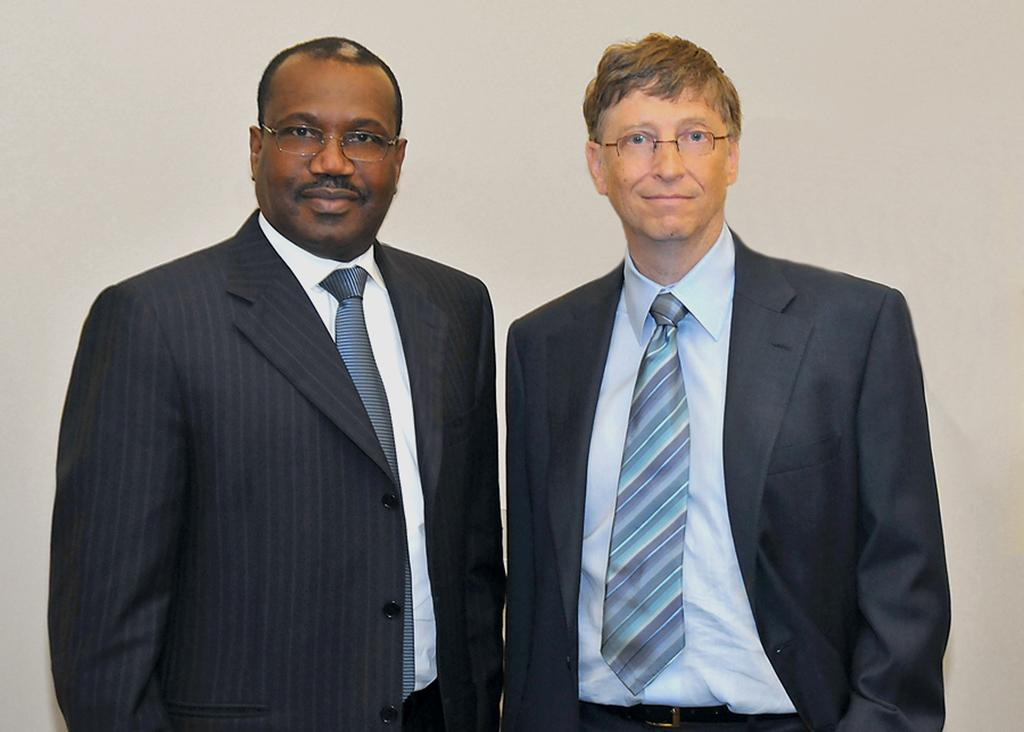How many people are in the image? There are two people in the image. What are the people doing in the image? Both people are standing. What expression do the people have in the image? The people are smiling. What record did the people break in the image? There is no record-breaking activity depicted in the image; the people are simply standing and smiling. 